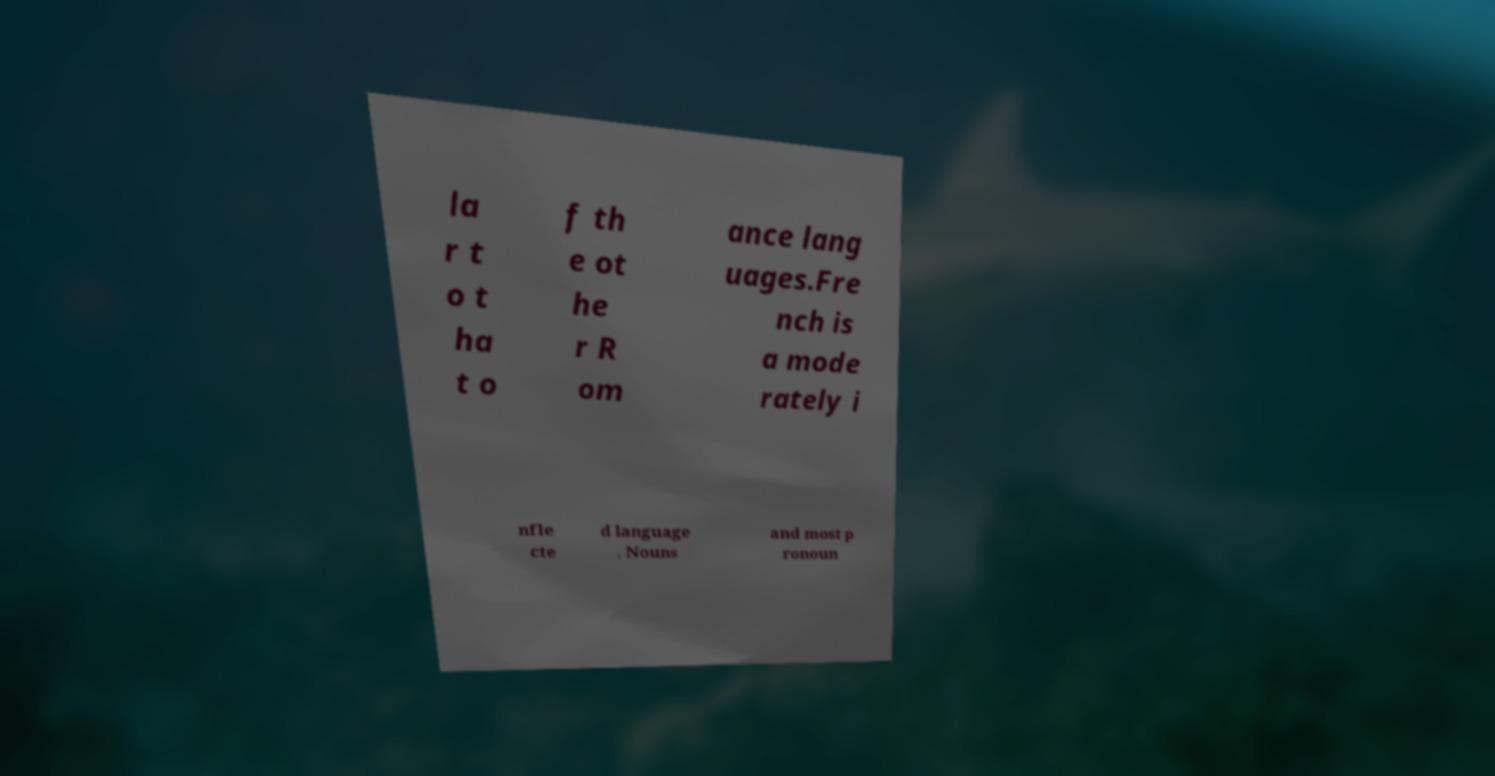For documentation purposes, I need the text within this image transcribed. Could you provide that? la r t o t ha t o f th e ot he r R om ance lang uages.Fre nch is a mode rately i nfle cte d language . Nouns and most p ronoun 